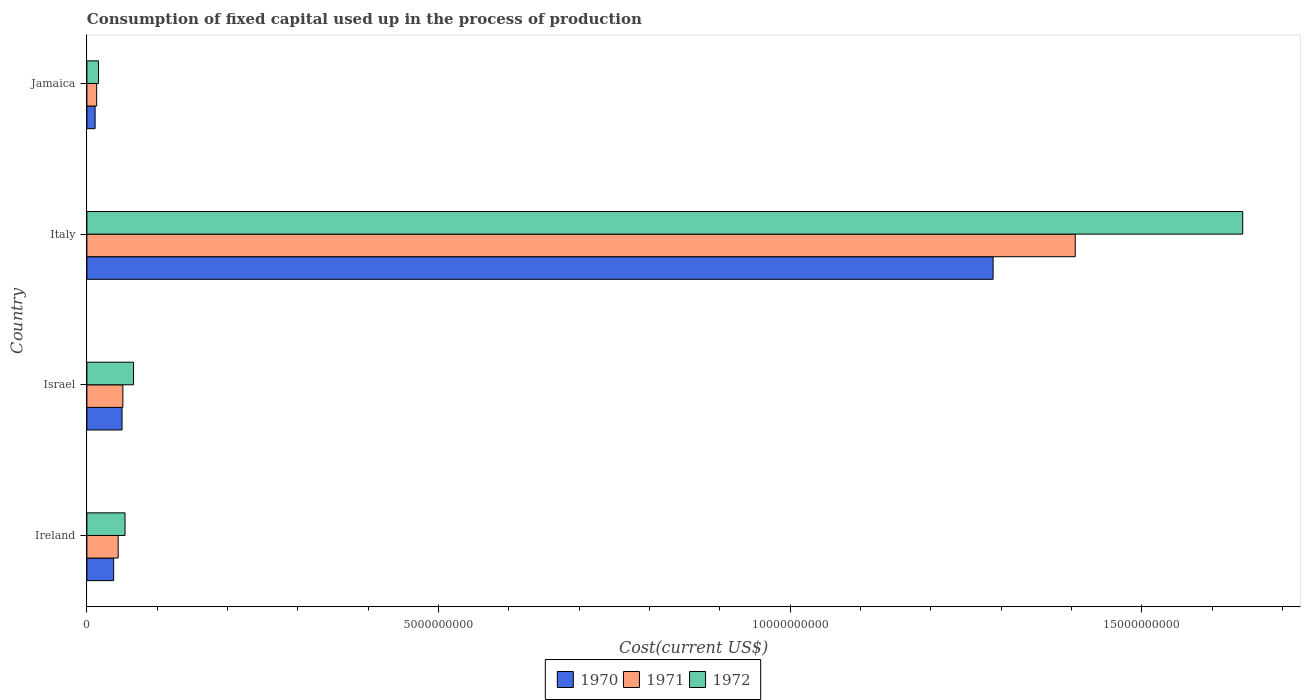In how many cases, is the number of bars for a given country not equal to the number of legend labels?
Keep it short and to the point. 0. What is the amount consumed in the process of production in 1970 in Israel?
Ensure brevity in your answer.  5.00e+08. Across all countries, what is the maximum amount consumed in the process of production in 1971?
Make the answer very short. 1.41e+1. Across all countries, what is the minimum amount consumed in the process of production in 1970?
Your answer should be very brief. 1.17e+08. In which country was the amount consumed in the process of production in 1972 minimum?
Provide a succinct answer. Jamaica. What is the total amount consumed in the process of production in 1970 in the graph?
Provide a succinct answer. 1.39e+1. What is the difference between the amount consumed in the process of production in 1970 in Israel and that in Italy?
Your answer should be very brief. -1.24e+1. What is the difference between the amount consumed in the process of production in 1972 in Israel and the amount consumed in the process of production in 1970 in Italy?
Offer a very short reply. -1.22e+1. What is the average amount consumed in the process of production in 1970 per country?
Provide a short and direct response. 3.47e+09. What is the difference between the amount consumed in the process of production in 1972 and amount consumed in the process of production in 1971 in Italy?
Your answer should be very brief. 2.38e+09. In how many countries, is the amount consumed in the process of production in 1970 greater than 10000000000 US$?
Offer a terse response. 1. What is the ratio of the amount consumed in the process of production in 1970 in Israel to that in Jamaica?
Keep it short and to the point. 4.28. Is the amount consumed in the process of production in 1972 in Ireland less than that in Jamaica?
Your answer should be compact. No. Is the difference between the amount consumed in the process of production in 1972 in Ireland and Jamaica greater than the difference between the amount consumed in the process of production in 1971 in Ireland and Jamaica?
Give a very brief answer. Yes. What is the difference between the highest and the second highest amount consumed in the process of production in 1971?
Make the answer very short. 1.35e+1. What is the difference between the highest and the lowest amount consumed in the process of production in 1972?
Offer a terse response. 1.63e+1. Is the sum of the amount consumed in the process of production in 1972 in Israel and Italy greater than the maximum amount consumed in the process of production in 1970 across all countries?
Your response must be concise. Yes. What does the 1st bar from the top in Israel represents?
Give a very brief answer. 1972. Are all the bars in the graph horizontal?
Provide a succinct answer. Yes. How many countries are there in the graph?
Make the answer very short. 4. Does the graph contain any zero values?
Provide a succinct answer. No. Does the graph contain grids?
Provide a short and direct response. No. How many legend labels are there?
Make the answer very short. 3. How are the legend labels stacked?
Offer a terse response. Horizontal. What is the title of the graph?
Offer a very short reply. Consumption of fixed capital used up in the process of production. Does "1975" appear as one of the legend labels in the graph?
Ensure brevity in your answer.  No. What is the label or title of the X-axis?
Your response must be concise. Cost(current US$). What is the label or title of the Y-axis?
Offer a terse response. Country. What is the Cost(current US$) of 1970 in Ireland?
Ensure brevity in your answer.  3.81e+08. What is the Cost(current US$) in 1971 in Ireland?
Keep it short and to the point. 4.45e+08. What is the Cost(current US$) of 1972 in Ireland?
Give a very brief answer. 5.42e+08. What is the Cost(current US$) in 1970 in Israel?
Make the answer very short. 5.00e+08. What is the Cost(current US$) in 1971 in Israel?
Your answer should be very brief. 5.12e+08. What is the Cost(current US$) in 1972 in Israel?
Give a very brief answer. 6.63e+08. What is the Cost(current US$) of 1970 in Italy?
Provide a succinct answer. 1.29e+1. What is the Cost(current US$) of 1971 in Italy?
Your answer should be compact. 1.41e+1. What is the Cost(current US$) of 1972 in Italy?
Provide a short and direct response. 1.64e+1. What is the Cost(current US$) in 1970 in Jamaica?
Keep it short and to the point. 1.17e+08. What is the Cost(current US$) of 1971 in Jamaica?
Provide a succinct answer. 1.39e+08. What is the Cost(current US$) of 1972 in Jamaica?
Offer a terse response. 1.65e+08. Across all countries, what is the maximum Cost(current US$) of 1970?
Give a very brief answer. 1.29e+1. Across all countries, what is the maximum Cost(current US$) of 1971?
Offer a terse response. 1.41e+1. Across all countries, what is the maximum Cost(current US$) in 1972?
Your answer should be very brief. 1.64e+1. Across all countries, what is the minimum Cost(current US$) of 1970?
Provide a succinct answer. 1.17e+08. Across all countries, what is the minimum Cost(current US$) of 1971?
Provide a short and direct response. 1.39e+08. Across all countries, what is the minimum Cost(current US$) of 1972?
Give a very brief answer. 1.65e+08. What is the total Cost(current US$) in 1970 in the graph?
Provide a succinct answer. 1.39e+1. What is the total Cost(current US$) in 1971 in the graph?
Your response must be concise. 1.51e+1. What is the total Cost(current US$) of 1972 in the graph?
Ensure brevity in your answer.  1.78e+1. What is the difference between the Cost(current US$) of 1970 in Ireland and that in Israel?
Offer a terse response. -1.19e+08. What is the difference between the Cost(current US$) in 1971 in Ireland and that in Israel?
Ensure brevity in your answer.  -6.70e+07. What is the difference between the Cost(current US$) of 1972 in Ireland and that in Israel?
Ensure brevity in your answer.  -1.21e+08. What is the difference between the Cost(current US$) in 1970 in Ireland and that in Italy?
Your response must be concise. -1.25e+1. What is the difference between the Cost(current US$) of 1971 in Ireland and that in Italy?
Offer a very short reply. -1.36e+1. What is the difference between the Cost(current US$) of 1972 in Ireland and that in Italy?
Offer a terse response. -1.59e+1. What is the difference between the Cost(current US$) in 1970 in Ireland and that in Jamaica?
Make the answer very short. 2.64e+08. What is the difference between the Cost(current US$) of 1971 in Ireland and that in Jamaica?
Provide a short and direct response. 3.06e+08. What is the difference between the Cost(current US$) of 1972 in Ireland and that in Jamaica?
Give a very brief answer. 3.77e+08. What is the difference between the Cost(current US$) of 1970 in Israel and that in Italy?
Your answer should be very brief. -1.24e+1. What is the difference between the Cost(current US$) of 1971 in Israel and that in Italy?
Give a very brief answer. -1.35e+1. What is the difference between the Cost(current US$) in 1972 in Israel and that in Italy?
Your answer should be very brief. -1.58e+1. What is the difference between the Cost(current US$) in 1970 in Israel and that in Jamaica?
Keep it short and to the point. 3.83e+08. What is the difference between the Cost(current US$) in 1971 in Israel and that in Jamaica?
Your answer should be very brief. 3.73e+08. What is the difference between the Cost(current US$) of 1972 in Israel and that in Jamaica?
Keep it short and to the point. 4.98e+08. What is the difference between the Cost(current US$) of 1970 in Italy and that in Jamaica?
Your answer should be very brief. 1.28e+1. What is the difference between the Cost(current US$) in 1971 in Italy and that in Jamaica?
Provide a short and direct response. 1.39e+1. What is the difference between the Cost(current US$) of 1972 in Italy and that in Jamaica?
Provide a short and direct response. 1.63e+1. What is the difference between the Cost(current US$) in 1970 in Ireland and the Cost(current US$) in 1971 in Israel?
Ensure brevity in your answer.  -1.31e+08. What is the difference between the Cost(current US$) of 1970 in Ireland and the Cost(current US$) of 1972 in Israel?
Provide a short and direct response. -2.83e+08. What is the difference between the Cost(current US$) in 1971 in Ireland and the Cost(current US$) in 1972 in Israel?
Offer a very short reply. -2.19e+08. What is the difference between the Cost(current US$) of 1970 in Ireland and the Cost(current US$) of 1971 in Italy?
Give a very brief answer. -1.37e+1. What is the difference between the Cost(current US$) in 1970 in Ireland and the Cost(current US$) in 1972 in Italy?
Ensure brevity in your answer.  -1.61e+1. What is the difference between the Cost(current US$) of 1971 in Ireland and the Cost(current US$) of 1972 in Italy?
Provide a succinct answer. -1.60e+1. What is the difference between the Cost(current US$) of 1970 in Ireland and the Cost(current US$) of 1971 in Jamaica?
Your response must be concise. 2.42e+08. What is the difference between the Cost(current US$) of 1970 in Ireland and the Cost(current US$) of 1972 in Jamaica?
Provide a succinct answer. 2.16e+08. What is the difference between the Cost(current US$) of 1971 in Ireland and the Cost(current US$) of 1972 in Jamaica?
Offer a very short reply. 2.80e+08. What is the difference between the Cost(current US$) of 1970 in Israel and the Cost(current US$) of 1971 in Italy?
Give a very brief answer. -1.36e+1. What is the difference between the Cost(current US$) in 1970 in Israel and the Cost(current US$) in 1972 in Italy?
Offer a terse response. -1.59e+1. What is the difference between the Cost(current US$) in 1971 in Israel and the Cost(current US$) in 1972 in Italy?
Provide a succinct answer. -1.59e+1. What is the difference between the Cost(current US$) in 1970 in Israel and the Cost(current US$) in 1971 in Jamaica?
Your answer should be very brief. 3.61e+08. What is the difference between the Cost(current US$) in 1970 in Israel and the Cost(current US$) in 1972 in Jamaica?
Ensure brevity in your answer.  3.35e+08. What is the difference between the Cost(current US$) in 1971 in Israel and the Cost(current US$) in 1972 in Jamaica?
Ensure brevity in your answer.  3.47e+08. What is the difference between the Cost(current US$) of 1970 in Italy and the Cost(current US$) of 1971 in Jamaica?
Give a very brief answer. 1.27e+1. What is the difference between the Cost(current US$) of 1970 in Italy and the Cost(current US$) of 1972 in Jamaica?
Make the answer very short. 1.27e+1. What is the difference between the Cost(current US$) in 1971 in Italy and the Cost(current US$) in 1972 in Jamaica?
Your response must be concise. 1.39e+1. What is the average Cost(current US$) in 1970 per country?
Your answer should be very brief. 3.47e+09. What is the average Cost(current US$) in 1971 per country?
Provide a succinct answer. 3.79e+09. What is the average Cost(current US$) in 1972 per country?
Provide a short and direct response. 4.45e+09. What is the difference between the Cost(current US$) in 1970 and Cost(current US$) in 1971 in Ireland?
Provide a succinct answer. -6.40e+07. What is the difference between the Cost(current US$) in 1970 and Cost(current US$) in 1972 in Ireland?
Offer a very short reply. -1.61e+08. What is the difference between the Cost(current US$) of 1971 and Cost(current US$) of 1972 in Ireland?
Give a very brief answer. -9.75e+07. What is the difference between the Cost(current US$) in 1970 and Cost(current US$) in 1971 in Israel?
Keep it short and to the point. -1.18e+07. What is the difference between the Cost(current US$) in 1970 and Cost(current US$) in 1972 in Israel?
Offer a very short reply. -1.63e+08. What is the difference between the Cost(current US$) of 1971 and Cost(current US$) of 1972 in Israel?
Ensure brevity in your answer.  -1.52e+08. What is the difference between the Cost(current US$) of 1970 and Cost(current US$) of 1971 in Italy?
Make the answer very short. -1.17e+09. What is the difference between the Cost(current US$) of 1970 and Cost(current US$) of 1972 in Italy?
Offer a terse response. -3.55e+09. What is the difference between the Cost(current US$) of 1971 and Cost(current US$) of 1972 in Italy?
Offer a very short reply. -2.38e+09. What is the difference between the Cost(current US$) in 1970 and Cost(current US$) in 1971 in Jamaica?
Your response must be concise. -2.23e+07. What is the difference between the Cost(current US$) in 1970 and Cost(current US$) in 1972 in Jamaica?
Your answer should be very brief. -4.81e+07. What is the difference between the Cost(current US$) of 1971 and Cost(current US$) of 1972 in Jamaica?
Provide a short and direct response. -2.58e+07. What is the ratio of the Cost(current US$) in 1970 in Ireland to that in Israel?
Make the answer very short. 0.76. What is the ratio of the Cost(current US$) in 1971 in Ireland to that in Israel?
Your response must be concise. 0.87. What is the ratio of the Cost(current US$) in 1972 in Ireland to that in Israel?
Make the answer very short. 0.82. What is the ratio of the Cost(current US$) of 1970 in Ireland to that in Italy?
Offer a terse response. 0.03. What is the ratio of the Cost(current US$) of 1971 in Ireland to that in Italy?
Provide a succinct answer. 0.03. What is the ratio of the Cost(current US$) of 1972 in Ireland to that in Italy?
Your answer should be compact. 0.03. What is the ratio of the Cost(current US$) of 1970 in Ireland to that in Jamaica?
Keep it short and to the point. 3.26. What is the ratio of the Cost(current US$) of 1971 in Ireland to that in Jamaica?
Your answer should be compact. 3.2. What is the ratio of the Cost(current US$) in 1972 in Ireland to that in Jamaica?
Offer a terse response. 3.29. What is the ratio of the Cost(current US$) of 1970 in Israel to that in Italy?
Your answer should be compact. 0.04. What is the ratio of the Cost(current US$) in 1971 in Israel to that in Italy?
Keep it short and to the point. 0.04. What is the ratio of the Cost(current US$) of 1972 in Israel to that in Italy?
Offer a very short reply. 0.04. What is the ratio of the Cost(current US$) in 1970 in Israel to that in Jamaica?
Keep it short and to the point. 4.28. What is the ratio of the Cost(current US$) in 1971 in Israel to that in Jamaica?
Your answer should be very brief. 3.68. What is the ratio of the Cost(current US$) of 1972 in Israel to that in Jamaica?
Make the answer very short. 4.02. What is the ratio of the Cost(current US$) in 1970 in Italy to that in Jamaica?
Offer a very short reply. 110.36. What is the ratio of the Cost(current US$) in 1971 in Italy to that in Jamaica?
Ensure brevity in your answer.  101.06. What is the ratio of the Cost(current US$) of 1972 in Italy to that in Jamaica?
Offer a very short reply. 99.71. What is the difference between the highest and the second highest Cost(current US$) in 1970?
Your answer should be compact. 1.24e+1. What is the difference between the highest and the second highest Cost(current US$) of 1971?
Give a very brief answer. 1.35e+1. What is the difference between the highest and the second highest Cost(current US$) in 1972?
Give a very brief answer. 1.58e+1. What is the difference between the highest and the lowest Cost(current US$) of 1970?
Ensure brevity in your answer.  1.28e+1. What is the difference between the highest and the lowest Cost(current US$) in 1971?
Ensure brevity in your answer.  1.39e+1. What is the difference between the highest and the lowest Cost(current US$) of 1972?
Give a very brief answer. 1.63e+1. 